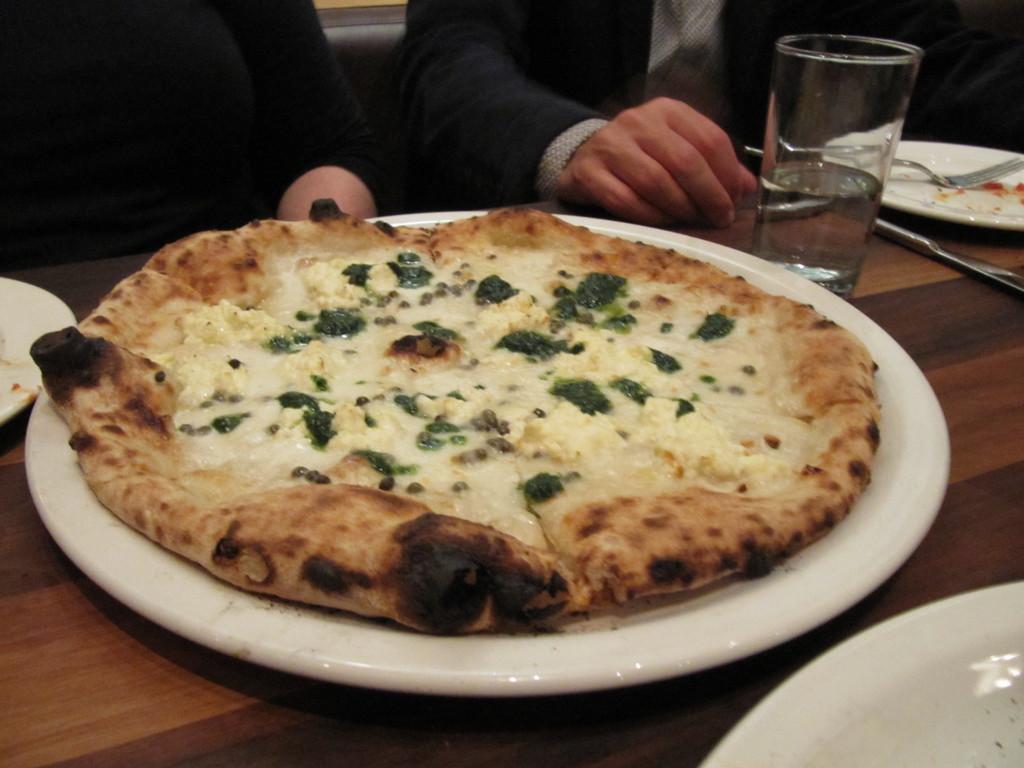Could you give a brief overview of what you see in this image? In this image there is a food item kept in a white color plate as we can see in middle of this image. There is one glass and a white color plate is kept on a table in the middle of this image. There is one plate in the bottom right corner of this image and one more plate is at left side of this image as well. There are two persons are sitting as we can see on the top of this image. 